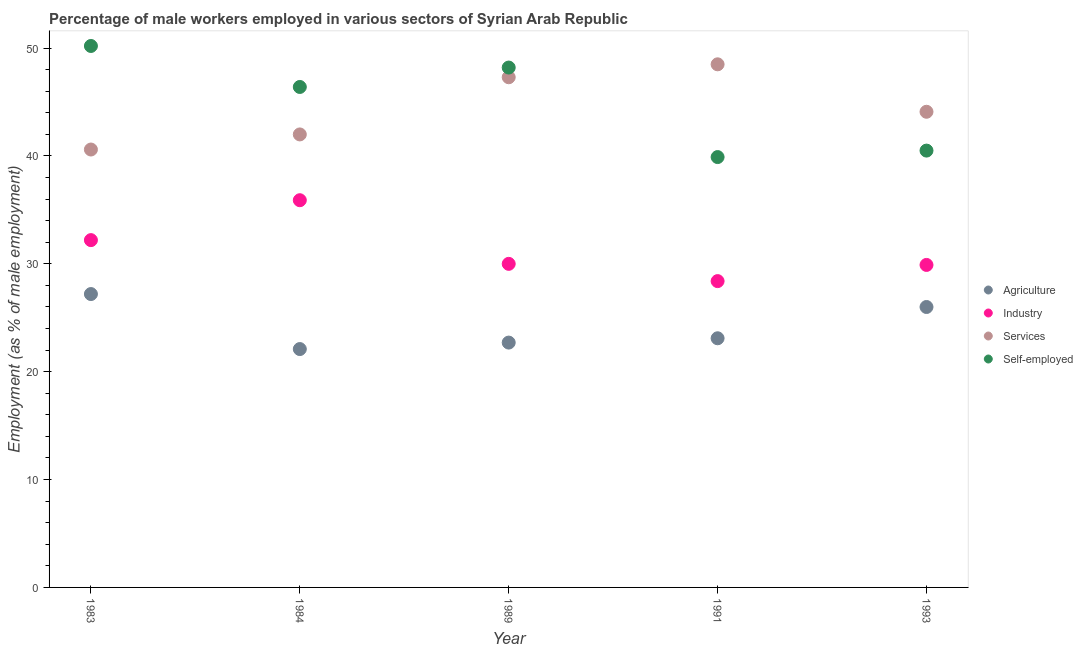How many different coloured dotlines are there?
Your answer should be compact. 4. Is the number of dotlines equal to the number of legend labels?
Keep it short and to the point. Yes. What is the percentage of male workers in services in 1991?
Provide a short and direct response. 48.5. Across all years, what is the maximum percentage of male workers in agriculture?
Your answer should be very brief. 27.2. Across all years, what is the minimum percentage of male workers in services?
Offer a very short reply. 40.6. In which year was the percentage of male workers in services maximum?
Provide a short and direct response. 1991. In which year was the percentage of male workers in industry minimum?
Provide a short and direct response. 1991. What is the total percentage of male workers in industry in the graph?
Offer a very short reply. 156.4. What is the difference between the percentage of male workers in industry in 1984 and that in 1989?
Provide a short and direct response. 5.9. What is the difference between the percentage of self employed male workers in 1989 and the percentage of male workers in agriculture in 1991?
Your answer should be compact. 25.1. What is the average percentage of self employed male workers per year?
Offer a terse response. 45.04. In the year 1991, what is the difference between the percentage of male workers in agriculture and percentage of self employed male workers?
Ensure brevity in your answer.  -16.8. What is the ratio of the percentage of self employed male workers in 1989 to that in 1991?
Keep it short and to the point. 1.21. Is the percentage of self employed male workers in 1983 less than that in 1991?
Give a very brief answer. No. Is the difference between the percentage of male workers in services in 1984 and 1991 greater than the difference between the percentage of male workers in industry in 1984 and 1991?
Your answer should be compact. No. What is the difference between the highest and the second highest percentage of self employed male workers?
Provide a short and direct response. 2. What is the difference between the highest and the lowest percentage of male workers in agriculture?
Keep it short and to the point. 5.1. In how many years, is the percentage of self employed male workers greater than the average percentage of self employed male workers taken over all years?
Your answer should be very brief. 3. Is it the case that in every year, the sum of the percentage of self employed male workers and percentage of male workers in services is greater than the sum of percentage of male workers in industry and percentage of male workers in agriculture?
Provide a succinct answer. Yes. Is it the case that in every year, the sum of the percentage of male workers in agriculture and percentage of male workers in industry is greater than the percentage of male workers in services?
Your answer should be compact. Yes. Does the percentage of self employed male workers monotonically increase over the years?
Keep it short and to the point. No. How many dotlines are there?
Keep it short and to the point. 4. What is the difference between two consecutive major ticks on the Y-axis?
Make the answer very short. 10. Are the values on the major ticks of Y-axis written in scientific E-notation?
Your response must be concise. No. Does the graph contain any zero values?
Your response must be concise. No. Does the graph contain grids?
Your response must be concise. No. Where does the legend appear in the graph?
Provide a succinct answer. Center right. What is the title of the graph?
Offer a terse response. Percentage of male workers employed in various sectors of Syrian Arab Republic. Does "Compensation of employees" appear as one of the legend labels in the graph?
Make the answer very short. No. What is the label or title of the X-axis?
Give a very brief answer. Year. What is the label or title of the Y-axis?
Ensure brevity in your answer.  Employment (as % of male employment). What is the Employment (as % of male employment) in Agriculture in 1983?
Ensure brevity in your answer.  27.2. What is the Employment (as % of male employment) in Industry in 1983?
Your response must be concise. 32.2. What is the Employment (as % of male employment) of Services in 1983?
Your answer should be very brief. 40.6. What is the Employment (as % of male employment) of Self-employed in 1983?
Your answer should be very brief. 50.2. What is the Employment (as % of male employment) of Agriculture in 1984?
Offer a very short reply. 22.1. What is the Employment (as % of male employment) of Industry in 1984?
Your answer should be very brief. 35.9. What is the Employment (as % of male employment) of Self-employed in 1984?
Your response must be concise. 46.4. What is the Employment (as % of male employment) in Agriculture in 1989?
Keep it short and to the point. 22.7. What is the Employment (as % of male employment) of Industry in 1989?
Provide a short and direct response. 30. What is the Employment (as % of male employment) in Services in 1989?
Give a very brief answer. 47.3. What is the Employment (as % of male employment) in Self-employed in 1989?
Keep it short and to the point. 48.2. What is the Employment (as % of male employment) of Agriculture in 1991?
Your answer should be very brief. 23.1. What is the Employment (as % of male employment) of Industry in 1991?
Your answer should be compact. 28.4. What is the Employment (as % of male employment) of Services in 1991?
Give a very brief answer. 48.5. What is the Employment (as % of male employment) in Self-employed in 1991?
Ensure brevity in your answer.  39.9. What is the Employment (as % of male employment) in Industry in 1993?
Give a very brief answer. 29.9. What is the Employment (as % of male employment) in Services in 1993?
Offer a very short reply. 44.1. What is the Employment (as % of male employment) of Self-employed in 1993?
Make the answer very short. 40.5. Across all years, what is the maximum Employment (as % of male employment) of Agriculture?
Keep it short and to the point. 27.2. Across all years, what is the maximum Employment (as % of male employment) of Industry?
Make the answer very short. 35.9. Across all years, what is the maximum Employment (as % of male employment) of Services?
Ensure brevity in your answer.  48.5. Across all years, what is the maximum Employment (as % of male employment) in Self-employed?
Your answer should be very brief. 50.2. Across all years, what is the minimum Employment (as % of male employment) of Agriculture?
Provide a short and direct response. 22.1. Across all years, what is the minimum Employment (as % of male employment) of Industry?
Give a very brief answer. 28.4. Across all years, what is the minimum Employment (as % of male employment) in Services?
Your answer should be compact. 40.6. Across all years, what is the minimum Employment (as % of male employment) in Self-employed?
Keep it short and to the point. 39.9. What is the total Employment (as % of male employment) in Agriculture in the graph?
Offer a very short reply. 121.1. What is the total Employment (as % of male employment) in Industry in the graph?
Give a very brief answer. 156.4. What is the total Employment (as % of male employment) in Services in the graph?
Make the answer very short. 222.5. What is the total Employment (as % of male employment) in Self-employed in the graph?
Provide a short and direct response. 225.2. What is the difference between the Employment (as % of male employment) of Agriculture in 1983 and that in 1984?
Make the answer very short. 5.1. What is the difference between the Employment (as % of male employment) of Industry in 1983 and that in 1989?
Give a very brief answer. 2.2. What is the difference between the Employment (as % of male employment) in Services in 1983 and that in 1989?
Give a very brief answer. -6.7. What is the difference between the Employment (as % of male employment) in Self-employed in 1983 and that in 1989?
Offer a very short reply. 2. What is the difference between the Employment (as % of male employment) in Agriculture in 1983 and that in 1991?
Provide a succinct answer. 4.1. What is the difference between the Employment (as % of male employment) of Services in 1983 and that in 1991?
Your response must be concise. -7.9. What is the difference between the Employment (as % of male employment) of Self-employed in 1983 and that in 1991?
Offer a very short reply. 10.3. What is the difference between the Employment (as % of male employment) in Agriculture in 1983 and that in 1993?
Give a very brief answer. 1.2. What is the difference between the Employment (as % of male employment) in Services in 1983 and that in 1993?
Provide a short and direct response. -3.5. What is the difference between the Employment (as % of male employment) in Industry in 1984 and that in 1989?
Provide a short and direct response. 5.9. What is the difference between the Employment (as % of male employment) in Self-employed in 1984 and that in 1989?
Provide a short and direct response. -1.8. What is the difference between the Employment (as % of male employment) of Services in 1984 and that in 1991?
Ensure brevity in your answer.  -6.5. What is the difference between the Employment (as % of male employment) in Self-employed in 1984 and that in 1991?
Keep it short and to the point. 6.5. What is the difference between the Employment (as % of male employment) of Industry in 1984 and that in 1993?
Keep it short and to the point. 6. What is the difference between the Employment (as % of male employment) of Self-employed in 1984 and that in 1993?
Ensure brevity in your answer.  5.9. What is the difference between the Employment (as % of male employment) in Services in 1989 and that in 1991?
Your answer should be compact. -1.2. What is the difference between the Employment (as % of male employment) of Agriculture in 1989 and that in 1993?
Give a very brief answer. -3.3. What is the difference between the Employment (as % of male employment) in Industry in 1989 and that in 1993?
Ensure brevity in your answer.  0.1. What is the difference between the Employment (as % of male employment) in Services in 1989 and that in 1993?
Keep it short and to the point. 3.2. What is the difference between the Employment (as % of male employment) of Self-employed in 1989 and that in 1993?
Your response must be concise. 7.7. What is the difference between the Employment (as % of male employment) of Agriculture in 1983 and the Employment (as % of male employment) of Industry in 1984?
Keep it short and to the point. -8.7. What is the difference between the Employment (as % of male employment) of Agriculture in 1983 and the Employment (as % of male employment) of Services in 1984?
Ensure brevity in your answer.  -14.8. What is the difference between the Employment (as % of male employment) of Agriculture in 1983 and the Employment (as % of male employment) of Self-employed in 1984?
Offer a terse response. -19.2. What is the difference between the Employment (as % of male employment) in Industry in 1983 and the Employment (as % of male employment) in Services in 1984?
Provide a short and direct response. -9.8. What is the difference between the Employment (as % of male employment) in Services in 1983 and the Employment (as % of male employment) in Self-employed in 1984?
Offer a terse response. -5.8. What is the difference between the Employment (as % of male employment) of Agriculture in 1983 and the Employment (as % of male employment) of Services in 1989?
Keep it short and to the point. -20.1. What is the difference between the Employment (as % of male employment) in Industry in 1983 and the Employment (as % of male employment) in Services in 1989?
Provide a succinct answer. -15.1. What is the difference between the Employment (as % of male employment) of Industry in 1983 and the Employment (as % of male employment) of Self-employed in 1989?
Make the answer very short. -16. What is the difference between the Employment (as % of male employment) of Services in 1983 and the Employment (as % of male employment) of Self-employed in 1989?
Your answer should be compact. -7.6. What is the difference between the Employment (as % of male employment) of Agriculture in 1983 and the Employment (as % of male employment) of Industry in 1991?
Your answer should be compact. -1.2. What is the difference between the Employment (as % of male employment) of Agriculture in 1983 and the Employment (as % of male employment) of Services in 1991?
Offer a terse response. -21.3. What is the difference between the Employment (as % of male employment) of Industry in 1983 and the Employment (as % of male employment) of Services in 1991?
Give a very brief answer. -16.3. What is the difference between the Employment (as % of male employment) in Services in 1983 and the Employment (as % of male employment) in Self-employed in 1991?
Offer a terse response. 0.7. What is the difference between the Employment (as % of male employment) of Agriculture in 1983 and the Employment (as % of male employment) of Services in 1993?
Provide a short and direct response. -16.9. What is the difference between the Employment (as % of male employment) in Agriculture in 1984 and the Employment (as % of male employment) in Services in 1989?
Keep it short and to the point. -25.2. What is the difference between the Employment (as % of male employment) in Agriculture in 1984 and the Employment (as % of male employment) in Self-employed in 1989?
Ensure brevity in your answer.  -26.1. What is the difference between the Employment (as % of male employment) of Industry in 1984 and the Employment (as % of male employment) of Services in 1989?
Offer a terse response. -11.4. What is the difference between the Employment (as % of male employment) of Industry in 1984 and the Employment (as % of male employment) of Self-employed in 1989?
Give a very brief answer. -12.3. What is the difference between the Employment (as % of male employment) of Services in 1984 and the Employment (as % of male employment) of Self-employed in 1989?
Your answer should be compact. -6.2. What is the difference between the Employment (as % of male employment) in Agriculture in 1984 and the Employment (as % of male employment) in Industry in 1991?
Ensure brevity in your answer.  -6.3. What is the difference between the Employment (as % of male employment) in Agriculture in 1984 and the Employment (as % of male employment) in Services in 1991?
Your answer should be compact. -26.4. What is the difference between the Employment (as % of male employment) of Agriculture in 1984 and the Employment (as % of male employment) of Self-employed in 1991?
Your answer should be very brief. -17.8. What is the difference between the Employment (as % of male employment) of Industry in 1984 and the Employment (as % of male employment) of Services in 1991?
Your answer should be compact. -12.6. What is the difference between the Employment (as % of male employment) of Industry in 1984 and the Employment (as % of male employment) of Self-employed in 1991?
Ensure brevity in your answer.  -4. What is the difference between the Employment (as % of male employment) of Agriculture in 1984 and the Employment (as % of male employment) of Industry in 1993?
Provide a succinct answer. -7.8. What is the difference between the Employment (as % of male employment) of Agriculture in 1984 and the Employment (as % of male employment) of Self-employed in 1993?
Your answer should be compact. -18.4. What is the difference between the Employment (as % of male employment) of Services in 1984 and the Employment (as % of male employment) of Self-employed in 1993?
Offer a terse response. 1.5. What is the difference between the Employment (as % of male employment) in Agriculture in 1989 and the Employment (as % of male employment) in Industry in 1991?
Give a very brief answer. -5.7. What is the difference between the Employment (as % of male employment) in Agriculture in 1989 and the Employment (as % of male employment) in Services in 1991?
Your response must be concise. -25.8. What is the difference between the Employment (as % of male employment) in Agriculture in 1989 and the Employment (as % of male employment) in Self-employed in 1991?
Provide a succinct answer. -17.2. What is the difference between the Employment (as % of male employment) in Industry in 1989 and the Employment (as % of male employment) in Services in 1991?
Make the answer very short. -18.5. What is the difference between the Employment (as % of male employment) of Industry in 1989 and the Employment (as % of male employment) of Self-employed in 1991?
Your answer should be compact. -9.9. What is the difference between the Employment (as % of male employment) in Services in 1989 and the Employment (as % of male employment) in Self-employed in 1991?
Give a very brief answer. 7.4. What is the difference between the Employment (as % of male employment) of Agriculture in 1989 and the Employment (as % of male employment) of Industry in 1993?
Make the answer very short. -7.2. What is the difference between the Employment (as % of male employment) in Agriculture in 1989 and the Employment (as % of male employment) in Services in 1993?
Provide a succinct answer. -21.4. What is the difference between the Employment (as % of male employment) in Agriculture in 1989 and the Employment (as % of male employment) in Self-employed in 1993?
Keep it short and to the point. -17.8. What is the difference between the Employment (as % of male employment) in Industry in 1989 and the Employment (as % of male employment) in Services in 1993?
Ensure brevity in your answer.  -14.1. What is the difference between the Employment (as % of male employment) of Services in 1989 and the Employment (as % of male employment) of Self-employed in 1993?
Provide a succinct answer. 6.8. What is the difference between the Employment (as % of male employment) of Agriculture in 1991 and the Employment (as % of male employment) of Industry in 1993?
Offer a terse response. -6.8. What is the difference between the Employment (as % of male employment) in Agriculture in 1991 and the Employment (as % of male employment) in Services in 1993?
Provide a succinct answer. -21. What is the difference between the Employment (as % of male employment) of Agriculture in 1991 and the Employment (as % of male employment) of Self-employed in 1993?
Your response must be concise. -17.4. What is the difference between the Employment (as % of male employment) of Industry in 1991 and the Employment (as % of male employment) of Services in 1993?
Ensure brevity in your answer.  -15.7. What is the difference between the Employment (as % of male employment) in Industry in 1991 and the Employment (as % of male employment) in Self-employed in 1993?
Your response must be concise. -12.1. What is the difference between the Employment (as % of male employment) of Services in 1991 and the Employment (as % of male employment) of Self-employed in 1993?
Give a very brief answer. 8. What is the average Employment (as % of male employment) in Agriculture per year?
Offer a terse response. 24.22. What is the average Employment (as % of male employment) of Industry per year?
Your response must be concise. 31.28. What is the average Employment (as % of male employment) of Services per year?
Your answer should be very brief. 44.5. What is the average Employment (as % of male employment) in Self-employed per year?
Keep it short and to the point. 45.04. In the year 1983, what is the difference between the Employment (as % of male employment) in Agriculture and Employment (as % of male employment) in Services?
Give a very brief answer. -13.4. In the year 1983, what is the difference between the Employment (as % of male employment) of Industry and Employment (as % of male employment) of Services?
Provide a succinct answer. -8.4. In the year 1983, what is the difference between the Employment (as % of male employment) of Services and Employment (as % of male employment) of Self-employed?
Your answer should be very brief. -9.6. In the year 1984, what is the difference between the Employment (as % of male employment) of Agriculture and Employment (as % of male employment) of Services?
Your answer should be compact. -19.9. In the year 1984, what is the difference between the Employment (as % of male employment) in Agriculture and Employment (as % of male employment) in Self-employed?
Your answer should be compact. -24.3. In the year 1984, what is the difference between the Employment (as % of male employment) in Industry and Employment (as % of male employment) in Services?
Keep it short and to the point. -6.1. In the year 1984, what is the difference between the Employment (as % of male employment) in Services and Employment (as % of male employment) in Self-employed?
Give a very brief answer. -4.4. In the year 1989, what is the difference between the Employment (as % of male employment) of Agriculture and Employment (as % of male employment) of Services?
Give a very brief answer. -24.6. In the year 1989, what is the difference between the Employment (as % of male employment) in Agriculture and Employment (as % of male employment) in Self-employed?
Keep it short and to the point. -25.5. In the year 1989, what is the difference between the Employment (as % of male employment) in Industry and Employment (as % of male employment) in Services?
Make the answer very short. -17.3. In the year 1989, what is the difference between the Employment (as % of male employment) in Industry and Employment (as % of male employment) in Self-employed?
Provide a succinct answer. -18.2. In the year 1991, what is the difference between the Employment (as % of male employment) in Agriculture and Employment (as % of male employment) in Industry?
Provide a succinct answer. -5.3. In the year 1991, what is the difference between the Employment (as % of male employment) of Agriculture and Employment (as % of male employment) of Services?
Your answer should be very brief. -25.4. In the year 1991, what is the difference between the Employment (as % of male employment) of Agriculture and Employment (as % of male employment) of Self-employed?
Provide a succinct answer. -16.8. In the year 1991, what is the difference between the Employment (as % of male employment) of Industry and Employment (as % of male employment) of Services?
Give a very brief answer. -20.1. In the year 1991, what is the difference between the Employment (as % of male employment) in Industry and Employment (as % of male employment) in Self-employed?
Provide a succinct answer. -11.5. In the year 1991, what is the difference between the Employment (as % of male employment) in Services and Employment (as % of male employment) in Self-employed?
Offer a very short reply. 8.6. In the year 1993, what is the difference between the Employment (as % of male employment) in Agriculture and Employment (as % of male employment) in Industry?
Ensure brevity in your answer.  -3.9. In the year 1993, what is the difference between the Employment (as % of male employment) in Agriculture and Employment (as % of male employment) in Services?
Provide a succinct answer. -18.1. In the year 1993, what is the difference between the Employment (as % of male employment) in Agriculture and Employment (as % of male employment) in Self-employed?
Your answer should be very brief. -14.5. In the year 1993, what is the difference between the Employment (as % of male employment) of Industry and Employment (as % of male employment) of Services?
Make the answer very short. -14.2. In the year 1993, what is the difference between the Employment (as % of male employment) of Industry and Employment (as % of male employment) of Self-employed?
Give a very brief answer. -10.6. In the year 1993, what is the difference between the Employment (as % of male employment) of Services and Employment (as % of male employment) of Self-employed?
Your response must be concise. 3.6. What is the ratio of the Employment (as % of male employment) in Agriculture in 1983 to that in 1984?
Ensure brevity in your answer.  1.23. What is the ratio of the Employment (as % of male employment) of Industry in 1983 to that in 1984?
Offer a terse response. 0.9. What is the ratio of the Employment (as % of male employment) in Services in 1983 to that in 1984?
Make the answer very short. 0.97. What is the ratio of the Employment (as % of male employment) in Self-employed in 1983 to that in 1984?
Your answer should be very brief. 1.08. What is the ratio of the Employment (as % of male employment) of Agriculture in 1983 to that in 1989?
Provide a short and direct response. 1.2. What is the ratio of the Employment (as % of male employment) in Industry in 1983 to that in 1989?
Offer a terse response. 1.07. What is the ratio of the Employment (as % of male employment) of Services in 1983 to that in 1989?
Provide a short and direct response. 0.86. What is the ratio of the Employment (as % of male employment) of Self-employed in 1983 to that in 1989?
Give a very brief answer. 1.04. What is the ratio of the Employment (as % of male employment) in Agriculture in 1983 to that in 1991?
Offer a terse response. 1.18. What is the ratio of the Employment (as % of male employment) in Industry in 1983 to that in 1991?
Give a very brief answer. 1.13. What is the ratio of the Employment (as % of male employment) of Services in 1983 to that in 1991?
Provide a short and direct response. 0.84. What is the ratio of the Employment (as % of male employment) of Self-employed in 1983 to that in 1991?
Your answer should be compact. 1.26. What is the ratio of the Employment (as % of male employment) of Agriculture in 1983 to that in 1993?
Ensure brevity in your answer.  1.05. What is the ratio of the Employment (as % of male employment) of Services in 1983 to that in 1993?
Your answer should be compact. 0.92. What is the ratio of the Employment (as % of male employment) in Self-employed in 1983 to that in 1993?
Provide a succinct answer. 1.24. What is the ratio of the Employment (as % of male employment) in Agriculture in 1984 to that in 1989?
Offer a terse response. 0.97. What is the ratio of the Employment (as % of male employment) of Industry in 1984 to that in 1989?
Ensure brevity in your answer.  1.2. What is the ratio of the Employment (as % of male employment) of Services in 1984 to that in 1989?
Provide a short and direct response. 0.89. What is the ratio of the Employment (as % of male employment) in Self-employed in 1984 to that in 1989?
Your response must be concise. 0.96. What is the ratio of the Employment (as % of male employment) of Agriculture in 1984 to that in 1991?
Provide a short and direct response. 0.96. What is the ratio of the Employment (as % of male employment) of Industry in 1984 to that in 1991?
Make the answer very short. 1.26. What is the ratio of the Employment (as % of male employment) of Services in 1984 to that in 1991?
Offer a very short reply. 0.87. What is the ratio of the Employment (as % of male employment) in Self-employed in 1984 to that in 1991?
Make the answer very short. 1.16. What is the ratio of the Employment (as % of male employment) in Agriculture in 1984 to that in 1993?
Keep it short and to the point. 0.85. What is the ratio of the Employment (as % of male employment) in Industry in 1984 to that in 1993?
Provide a short and direct response. 1.2. What is the ratio of the Employment (as % of male employment) of Services in 1984 to that in 1993?
Give a very brief answer. 0.95. What is the ratio of the Employment (as % of male employment) of Self-employed in 1984 to that in 1993?
Your answer should be compact. 1.15. What is the ratio of the Employment (as % of male employment) of Agriculture in 1989 to that in 1991?
Keep it short and to the point. 0.98. What is the ratio of the Employment (as % of male employment) in Industry in 1989 to that in 1991?
Offer a very short reply. 1.06. What is the ratio of the Employment (as % of male employment) of Services in 1989 to that in 1991?
Provide a short and direct response. 0.98. What is the ratio of the Employment (as % of male employment) in Self-employed in 1989 to that in 1991?
Provide a short and direct response. 1.21. What is the ratio of the Employment (as % of male employment) of Agriculture in 1989 to that in 1993?
Your answer should be very brief. 0.87. What is the ratio of the Employment (as % of male employment) in Services in 1989 to that in 1993?
Give a very brief answer. 1.07. What is the ratio of the Employment (as % of male employment) of Self-employed in 1989 to that in 1993?
Provide a short and direct response. 1.19. What is the ratio of the Employment (as % of male employment) in Agriculture in 1991 to that in 1993?
Offer a very short reply. 0.89. What is the ratio of the Employment (as % of male employment) of Industry in 1991 to that in 1993?
Make the answer very short. 0.95. What is the ratio of the Employment (as % of male employment) in Services in 1991 to that in 1993?
Your answer should be very brief. 1.1. What is the ratio of the Employment (as % of male employment) of Self-employed in 1991 to that in 1993?
Give a very brief answer. 0.99. What is the difference between the highest and the second highest Employment (as % of male employment) of Self-employed?
Make the answer very short. 2. 